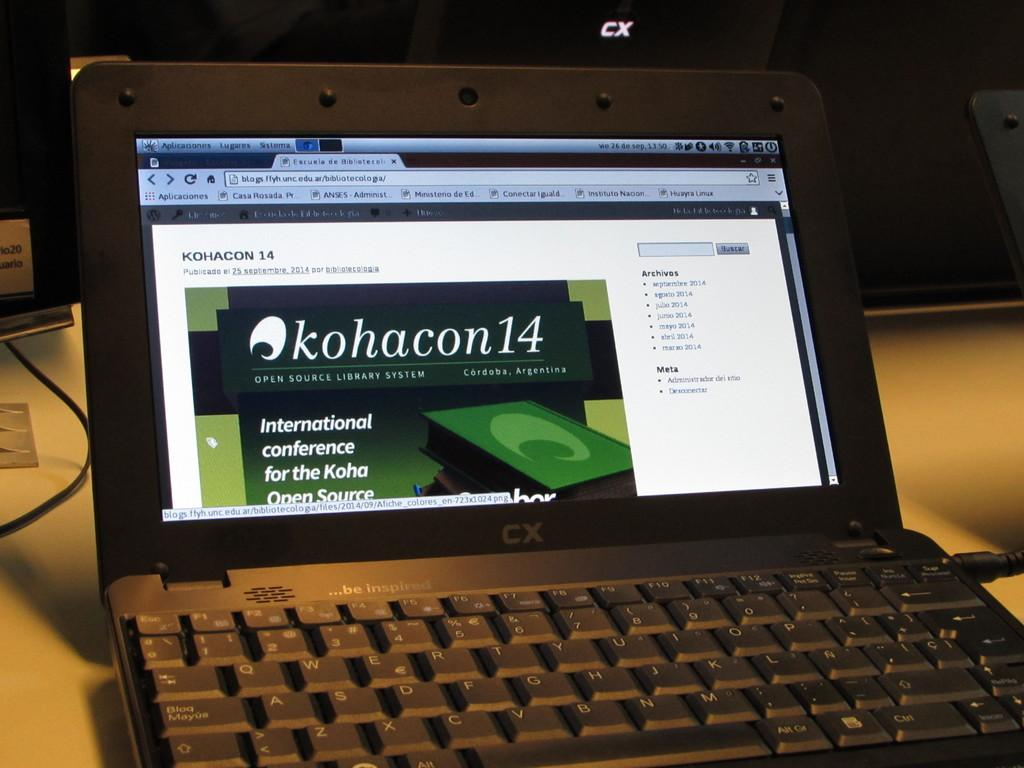<image>
Offer a succinct explanation of the picture presented. Kohacon 14 is the header of the site shown on this laptop screen. 